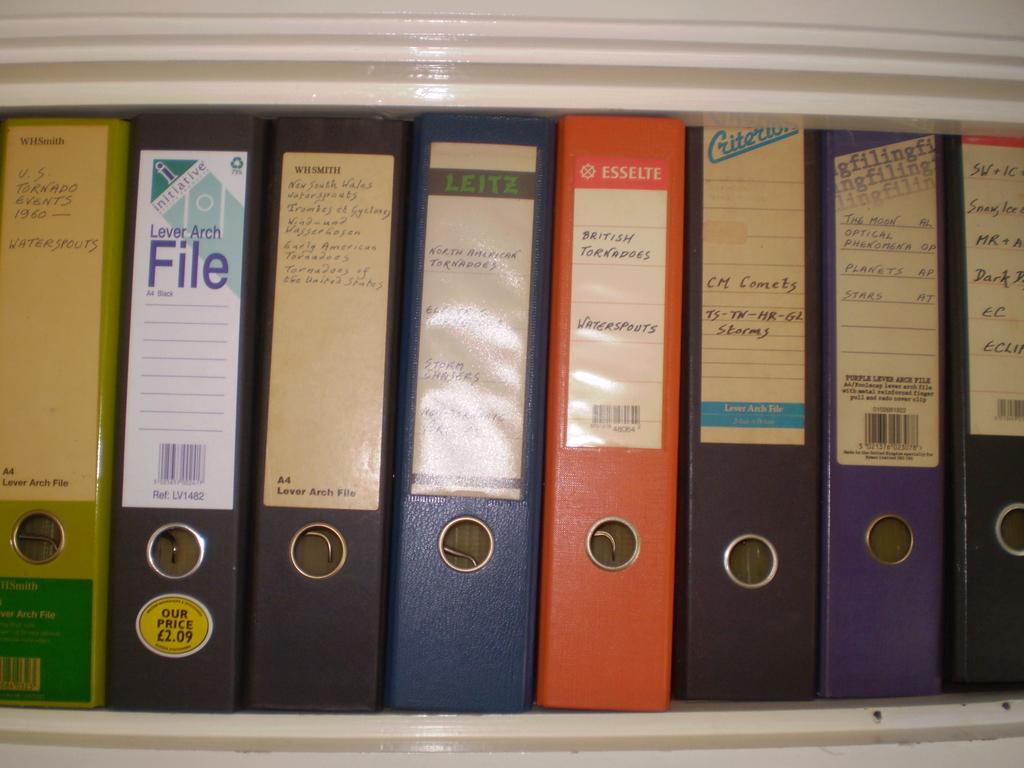Can you describe this image briefly? In this image we can see files are arranged in a white color shelf. 